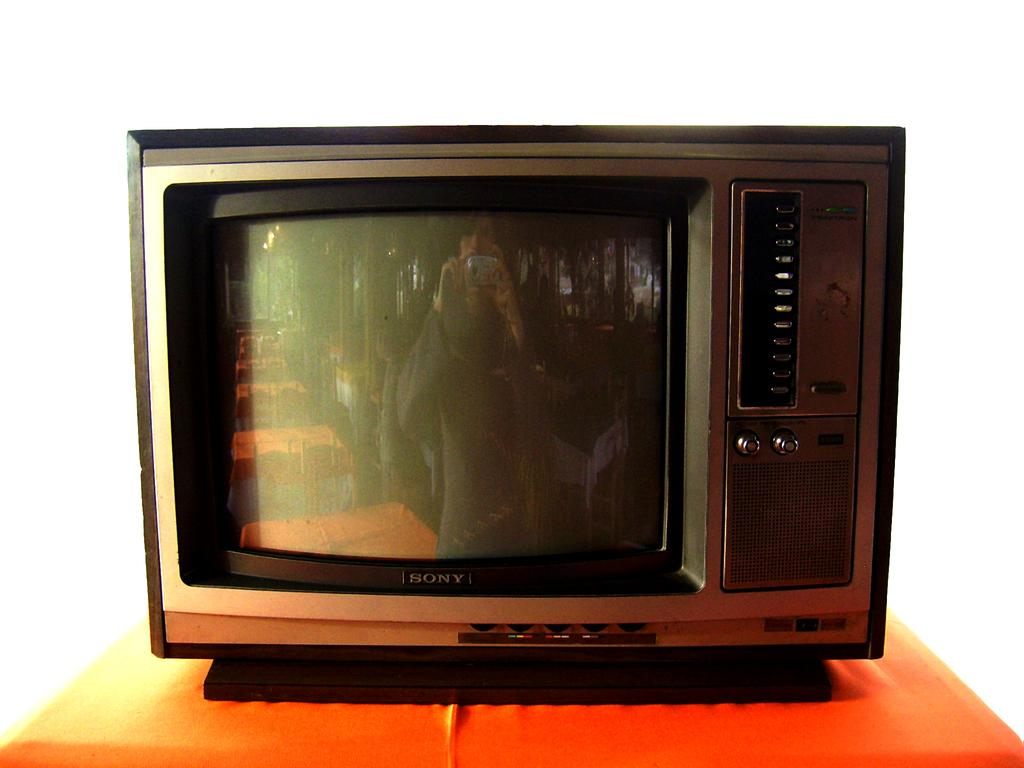<image>
Share a concise interpretation of the image provided. An old school Sony television sits on top of an orange table 